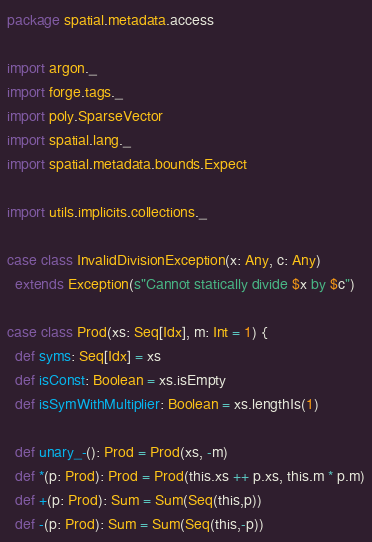<code> <loc_0><loc_0><loc_500><loc_500><_Scala_>package spatial.metadata.access

import argon._
import forge.tags._
import poly.SparseVector
import spatial.lang._
import spatial.metadata.bounds.Expect

import utils.implicits.collections._

case class InvalidDivisionException(x: Any, c: Any)
  extends Exception(s"Cannot statically divide $x by $c")

case class Prod(xs: Seq[Idx], m: Int = 1) {
  def syms: Seq[Idx] = xs
  def isConst: Boolean = xs.isEmpty
  def isSymWithMultiplier: Boolean = xs.lengthIs(1)

  def unary_-(): Prod = Prod(xs, -m)
  def *(p: Prod): Prod = Prod(this.xs ++ p.xs, this.m * p.m)
  def +(p: Prod): Sum = Sum(Seq(this,p))
  def -(p: Prod): Sum = Sum(Seq(this,-p))
</code> 